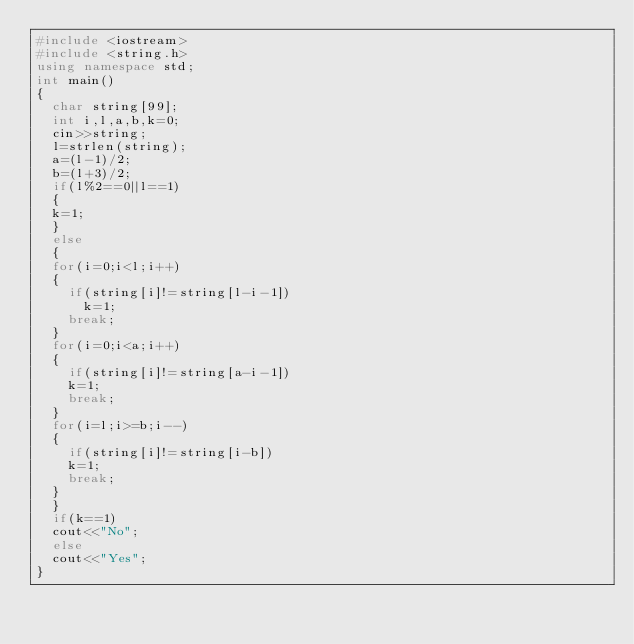Convert code to text. <code><loc_0><loc_0><loc_500><loc_500><_C++_>#include <iostream>
#include <string.h>
using namespace std;
int main()
{
  char string[99];
  int i,l,a,b,k=0;
  cin>>string;
  l=strlen(string);
  a=(l-1)/2;
  b=(l+3)/2;
  if(l%2==0||l==1)
  {
  k=1;
  }
  else
  {
  for(i=0;i<l;i++)
  {
    if(string[i]!=string[l-i-1])
      k=1;
    break;
  }
  for(i=0;i<a;i++)
  {  
    if(string[i]!=string[a-i-1])
    k=1;
    break;
  }
  for(i=l;i>=b;i--)
  {
    if(string[i]!=string[i-b])
    k=1;
    break;
  }
  }
  if(k==1)
  cout<<"No";
  else
  cout<<"Yes";
}
</code> 